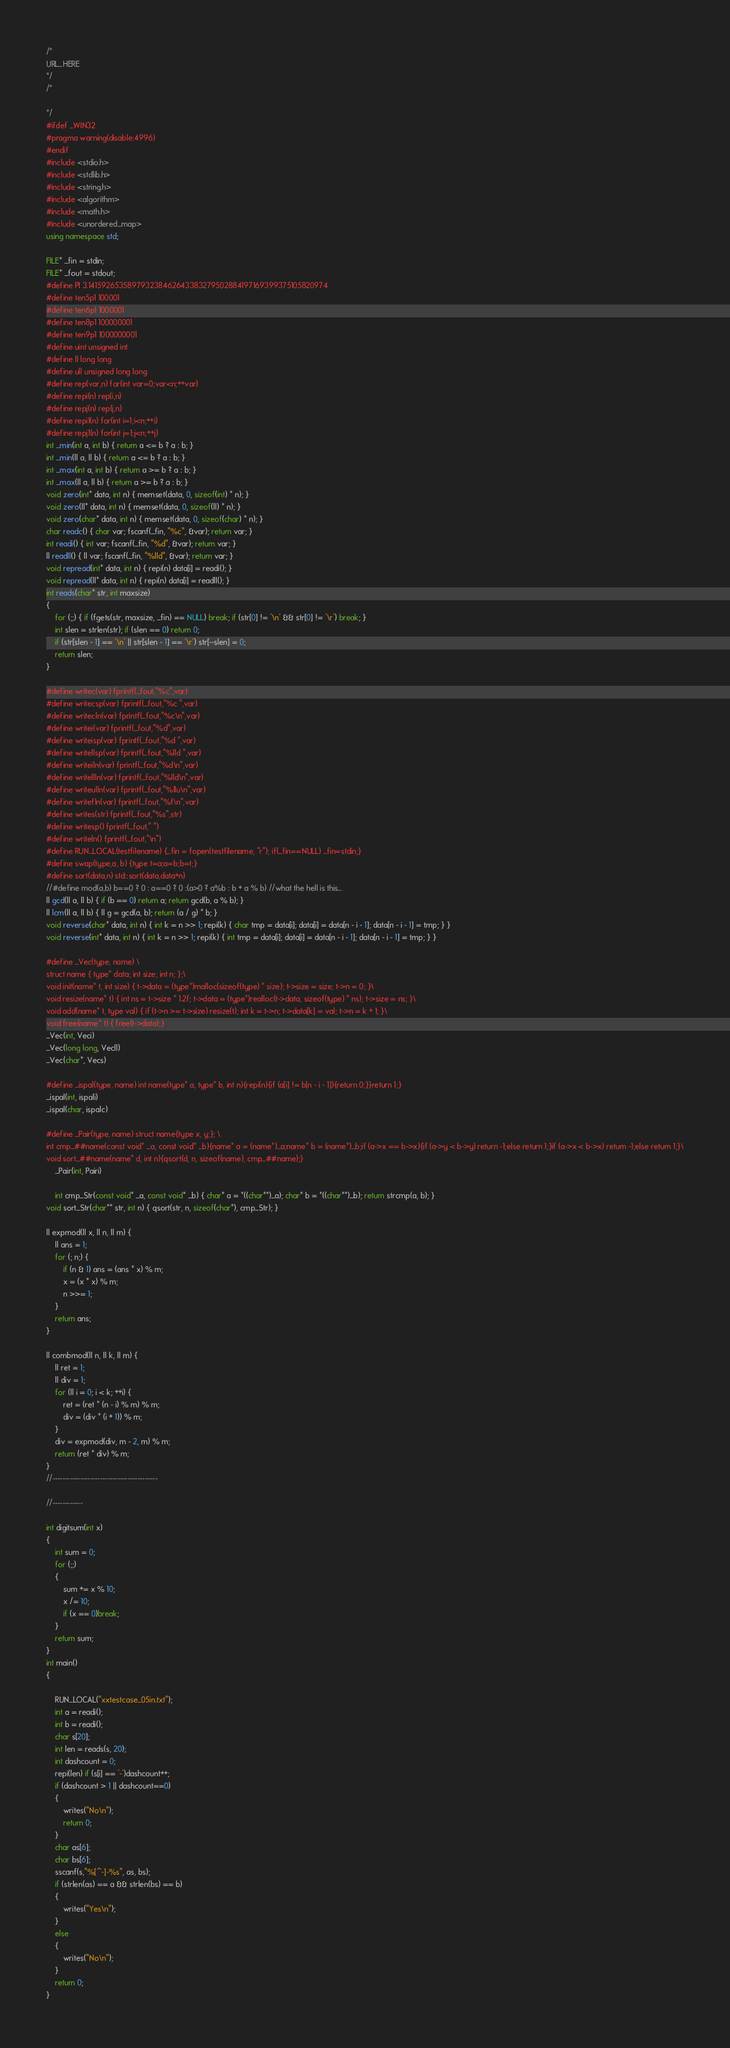<code> <loc_0><loc_0><loc_500><loc_500><_C++_>/*
URL_HERE
*/
/*

*/
#ifdef _WIN32
#pragma warning(disable:4996)
#endif
#include <stdio.h>
#include <stdlib.h>
#include <string.h>
#include <algorithm>
#include <math.h>
#include <unordered_map>
using namespace std;

FILE* _fin = stdin;
FILE* _fout = stdout;
#define PI 3.141592653589793238462643383279502884197169399375105820974
#define ten5p1 100001
#define ten6p1 1000001
#define ten8p1 100000001
#define ten9p1 1000000001
#define uint unsigned int
#define ll long long
#define ull unsigned long long
#define rep(var,n) for(int var=0;var<n;++var)
#define repi(n) rep(i,n)
#define repj(n) rep(j,n)
#define repi1(n) for(int i=1;i<n;++i)
#define repj1(n) for(int j=1;j<n;++j)
int _min(int a, int b) { return a <= b ? a : b; }
int _min(ll a, ll b) { return a <= b ? a : b; }
int _max(int a, int b) { return a >= b ? a : b; }
int _max(ll a, ll b) { return a >= b ? a : b; }
void zero(int* data, int n) { memset(data, 0, sizeof(int) * n); }
void zero(ll* data, int n) { memset(data, 0, sizeof(ll) * n); }
void zero(char* data, int n) { memset(data, 0, sizeof(char) * n); }
char readc() { char var; fscanf(_fin, "%c", &var); return var; }
int readi() { int var; fscanf(_fin, "%d", &var); return var; }
ll readll() { ll var; fscanf(_fin, "%lld", &var); return var; }
void repread(int* data, int n) { repi(n) data[i] = readi(); }
void repread(ll* data, int n) { repi(n) data[i] = readll(); }
int reads(char* str, int maxsize)
{
	for (;;) { if (fgets(str, maxsize, _fin) == NULL) break; if (str[0] != '\n' && str[0] != '\r') break; }
	int slen = strlen(str); if (slen == 0) return 0;
	if (str[slen - 1] == '\n' || str[slen - 1] == '\r') str[--slen] = 0;
	return slen;
}

#define writec(var) fprintf(_fout,"%c",var)
#define writecsp(var) fprintf(_fout,"%c ",var)
#define writecln(var) fprintf(_fout,"%c\n",var)
#define writei(var) fprintf(_fout,"%d",var)
#define writeisp(var) fprintf(_fout,"%d ",var)
#define writellsp(var) fprintf(_fout,"%lld ",var)
#define writeiln(var) fprintf(_fout,"%d\n",var)
#define writellln(var) fprintf(_fout,"%lld\n",var)
#define writeulln(var) fprintf(_fout,"%llu\n",var)
#define writefln(var) fprintf(_fout,"%f\n",var)
#define writes(str) fprintf(_fout,"%s",str)
#define writesp() fprintf(_fout," ")
#define writeln() fprintf(_fout,"\n")
#define RUN_LOCAL(testfilename) {_fin = fopen(testfilename, "r"); if(_fin==NULL) _fin=stdin;}
#define swap(type,a, b) {type t=a;a=b;b=t;}
#define sort(data,n) std::sort(data,data+n)
//#define mod(a,b) b==0 ? 0 : a==0 ? 0 :(a>0 ? a%b : b + a % b) //what the hell is this...
ll gcd(ll a, ll b) { if (b == 0) return a; return gcd(b, a % b); }
ll lcm(ll a, ll b) { ll g = gcd(a, b); return (a / g) * b; }
void reverse(char* data, int n) { int k = n >> 1; repi(k) { char tmp = data[i]; data[i] = data[n - i - 1]; data[n - i - 1] = tmp; } }
void reverse(int* data, int n) { int k = n >> 1; repi(k) { int tmp = data[i]; data[i] = data[n - i - 1]; data[n - i - 1] = tmp; } }

#define _Vec(type, name) \
struct name { type* data; int size; int n; };\
void init(name* t, int size) { t->data = (type*)malloc(sizeof(type) * size); t->size = size; t->n = 0; }\
void resize(name* t) { int ns = t->size * 1.2f; t->data = (type*)realloc(t->data, sizeof(type) * ns); t->size = ns; }\
void add(name* t, type val) { if (t->n >= t->size) resize(t); int k = t->n; t->data[k] = val; t->n = k + 1; }\
void free(name* t) { free(t->data);}
_Vec(int, Veci)
_Vec(long long, Vecll)
_Vec(char*, Vecs)

#define _ispal(type, name) int name(type* a, type* b, int n){repi(n){if (a[i] != b[n - i - 1]){return 0;}}return 1;}
_ispal(int, ispali)
_ispal(char, ispalc)

#define _Pair(type, name) struct name{type x, y;}; \
int cmp_##name(const void* _a, const void* _b){name* a = (name*)_a;name* b = (name*)_b;if (a->x == b->x){if (a->y < b->y) return -1;else return 1;}if (a->x < b->x) return -1;else return 1;}\
void sort_##name(name* d, int n){qsort(d, n, sizeof(name), cmp_##name);}
	_Pair(int, Pairi)

	int cmp_Str(const void* _a, const void* _b) { char* a = *((char**)_a); char* b = *((char**)_b); return strcmp(a, b); }
void sort_Str(char** str, int n) { qsort(str, n, sizeof(char*), cmp_Str); }

ll expmod(ll x, ll n, ll m) {
	ll ans = 1;
	for (; n;) {
		if (n & 1) ans = (ans * x) % m;
		x = (x * x) % m;
		n >>= 1;
	}
	return ans;
}

ll combmod(ll n, ll k, ll m) {
	ll ret = 1;
	ll div = 1;
	for (ll i = 0; i < k; ++i) {
		ret = (ret * (n - i) % m) % m;
		div = (div * (i + 1)) % m;
	}
	div = expmod(div, m - 2, m) % m;
	return (ret * div) % m;
}
//------------------------------------------

//------------

int digitsum(int x)
{
	int sum = 0;
	for (;;)
	{
		sum += x % 10;
		x /= 10;
		if (x == 0)break;
	}
	return sum;
}
int main()
{

	RUN_LOCAL("xxtestcase_05in.txt");
	int a = readi();
	int b = readi();
	char s[20];
	int len = reads(s, 20);
	int dashcount = 0;
	repi(len) if (s[i] == '-')dashcount++;
	if (dashcount > 1 || dashcount==0)
	{
		writes("No\n");
		return 0;
	}
	char as[6];
	char bs[6];
	sscanf(s,"%[^-]-%s", as, bs);
	if (strlen(as) == a && strlen(bs) == b)
	{
		writes("Yes\n");
	}
	else
	{
		writes("No\n");
	}
	return 0;
}
</code> 